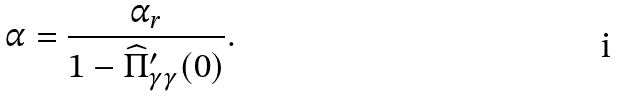<formula> <loc_0><loc_0><loc_500><loc_500>\alpha = \frac { \alpha _ { r } } { 1 - \widehat { \Pi } _ { \gamma \gamma } ^ { \prime } ( 0 ) } .</formula> 